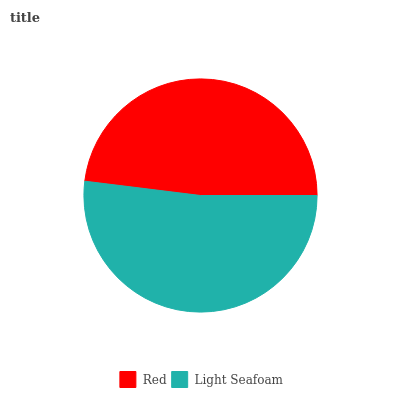Is Red the minimum?
Answer yes or no. Yes. Is Light Seafoam the maximum?
Answer yes or no. Yes. Is Light Seafoam the minimum?
Answer yes or no. No. Is Light Seafoam greater than Red?
Answer yes or no. Yes. Is Red less than Light Seafoam?
Answer yes or no. Yes. Is Red greater than Light Seafoam?
Answer yes or no. No. Is Light Seafoam less than Red?
Answer yes or no. No. Is Light Seafoam the high median?
Answer yes or no. Yes. Is Red the low median?
Answer yes or no. Yes. Is Red the high median?
Answer yes or no. No. Is Light Seafoam the low median?
Answer yes or no. No. 